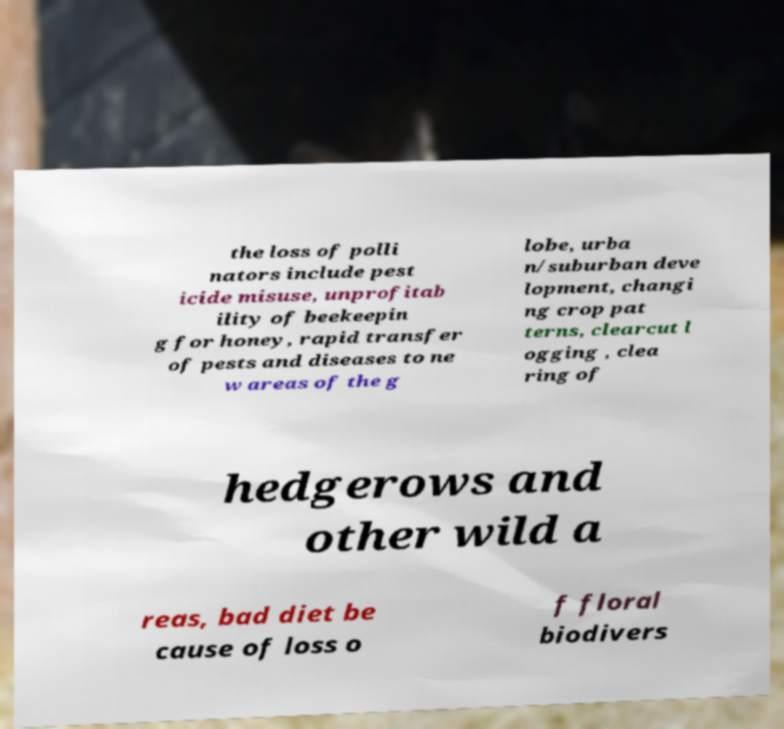Can you accurately transcribe the text from the provided image for me? the loss of polli nators include pest icide misuse, unprofitab ility of beekeepin g for honey, rapid transfer of pests and diseases to ne w areas of the g lobe, urba n/suburban deve lopment, changi ng crop pat terns, clearcut l ogging , clea ring of hedgerows and other wild a reas, bad diet be cause of loss o f floral biodivers 